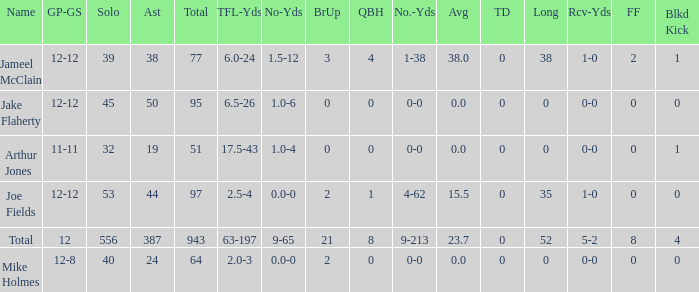How many yards for the player with tfl-yds of 2.5-4? 4-62. 